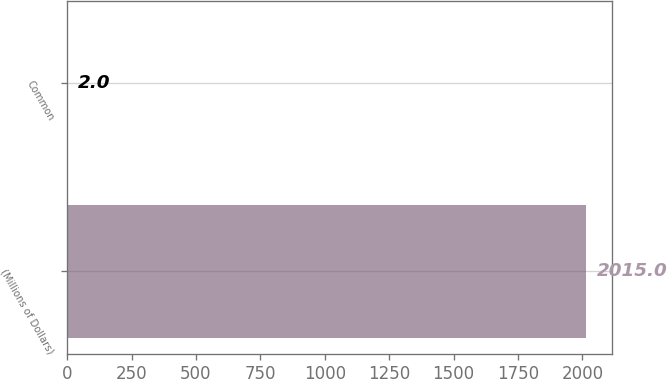<chart> <loc_0><loc_0><loc_500><loc_500><bar_chart><fcel>(Millions of Dollars)<fcel>Common<nl><fcel>2015<fcel>2<nl></chart> 